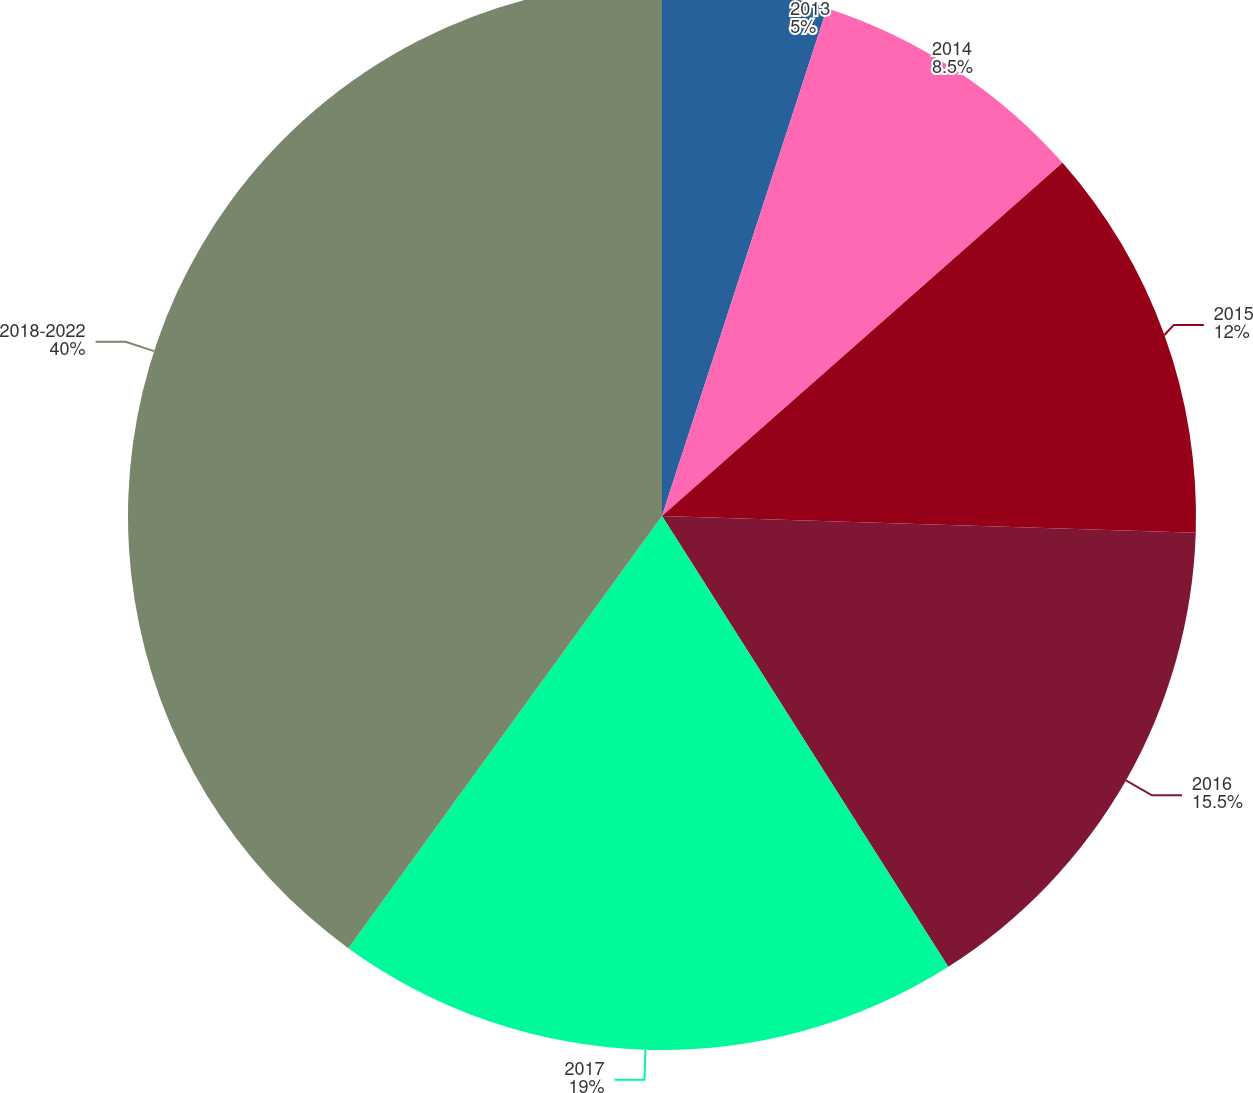Convert chart. <chart><loc_0><loc_0><loc_500><loc_500><pie_chart><fcel>2013<fcel>2014<fcel>2015<fcel>2016<fcel>2017<fcel>2018-2022<nl><fcel>5.0%<fcel>8.5%<fcel>12.0%<fcel>15.5%<fcel>19.0%<fcel>40.01%<nl></chart> 